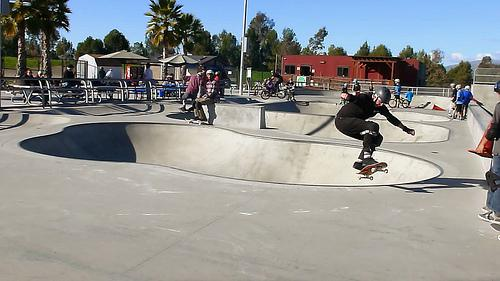Question: how are the shadows made?
Choices:
A. Candle.
B. Moonlight.
C. Lamp.
D. Sunlight.
Answer with the letter. Answer: D Question: where are the people?
Choices:
A. Skate park.
B. Skate rink.
C. Parking garage.
D. Parking lot.
Answer with the letter. Answer: A Question: what are the people doing?
Choices:
A. Walking.
B. Running.
C. Swimming.
D. Skateboarding.
Answer with the letter. Answer: D Question: who is in the picture?
Choices:
A. People.
B. Animals.
C. Robots.
D. Aliens.
Answer with the letter. Answer: A Question: what color is the building in the background?
Choices:
A. Red.
B. Orange.
C. Tan.
D. White.
Answer with the letter. Answer: A Question: why are the people wearing helmets?
Choices:
A. Mountain climbing.
B. Safety.
C. Exploring.
D. Building.
Answer with the letter. Answer: B 